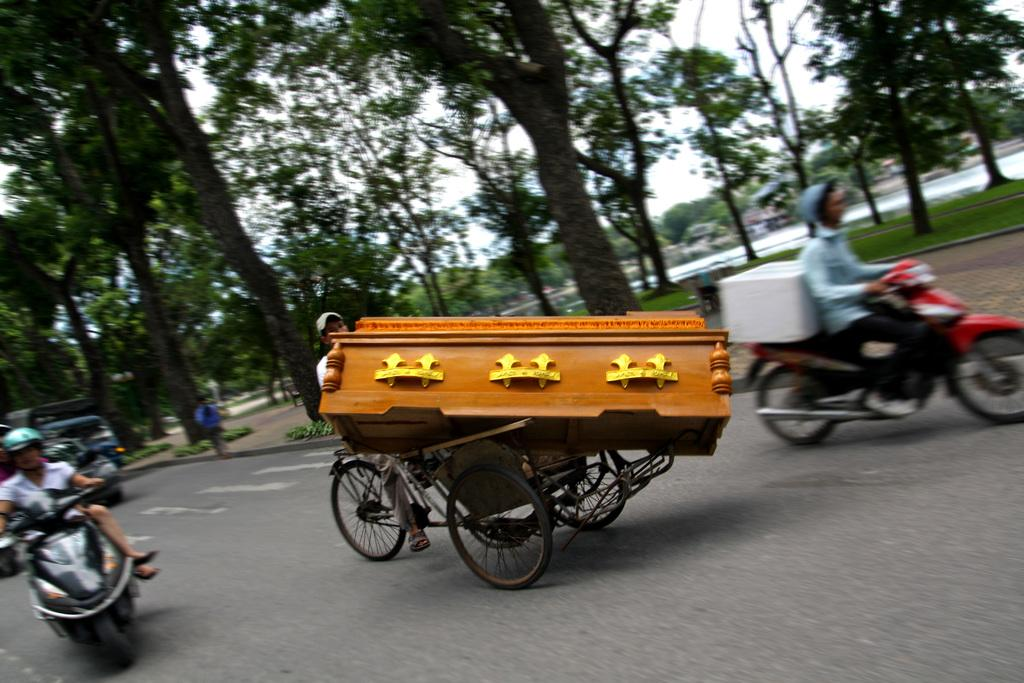What is the person in the image doing? There is a person sitting on a vehicle in the image. What can be seen on the vehicle with the person? There are wooden objects on the vehicle. What are the other people in the image doing? There are other people sitting on a bike in the image. What is visible in the background behind the bike? Trees are visible behind the bike. What flavor of net is being used by the person sitting on the vehicle? There is no net present in the image, and therefore no flavor can be associated with it. 